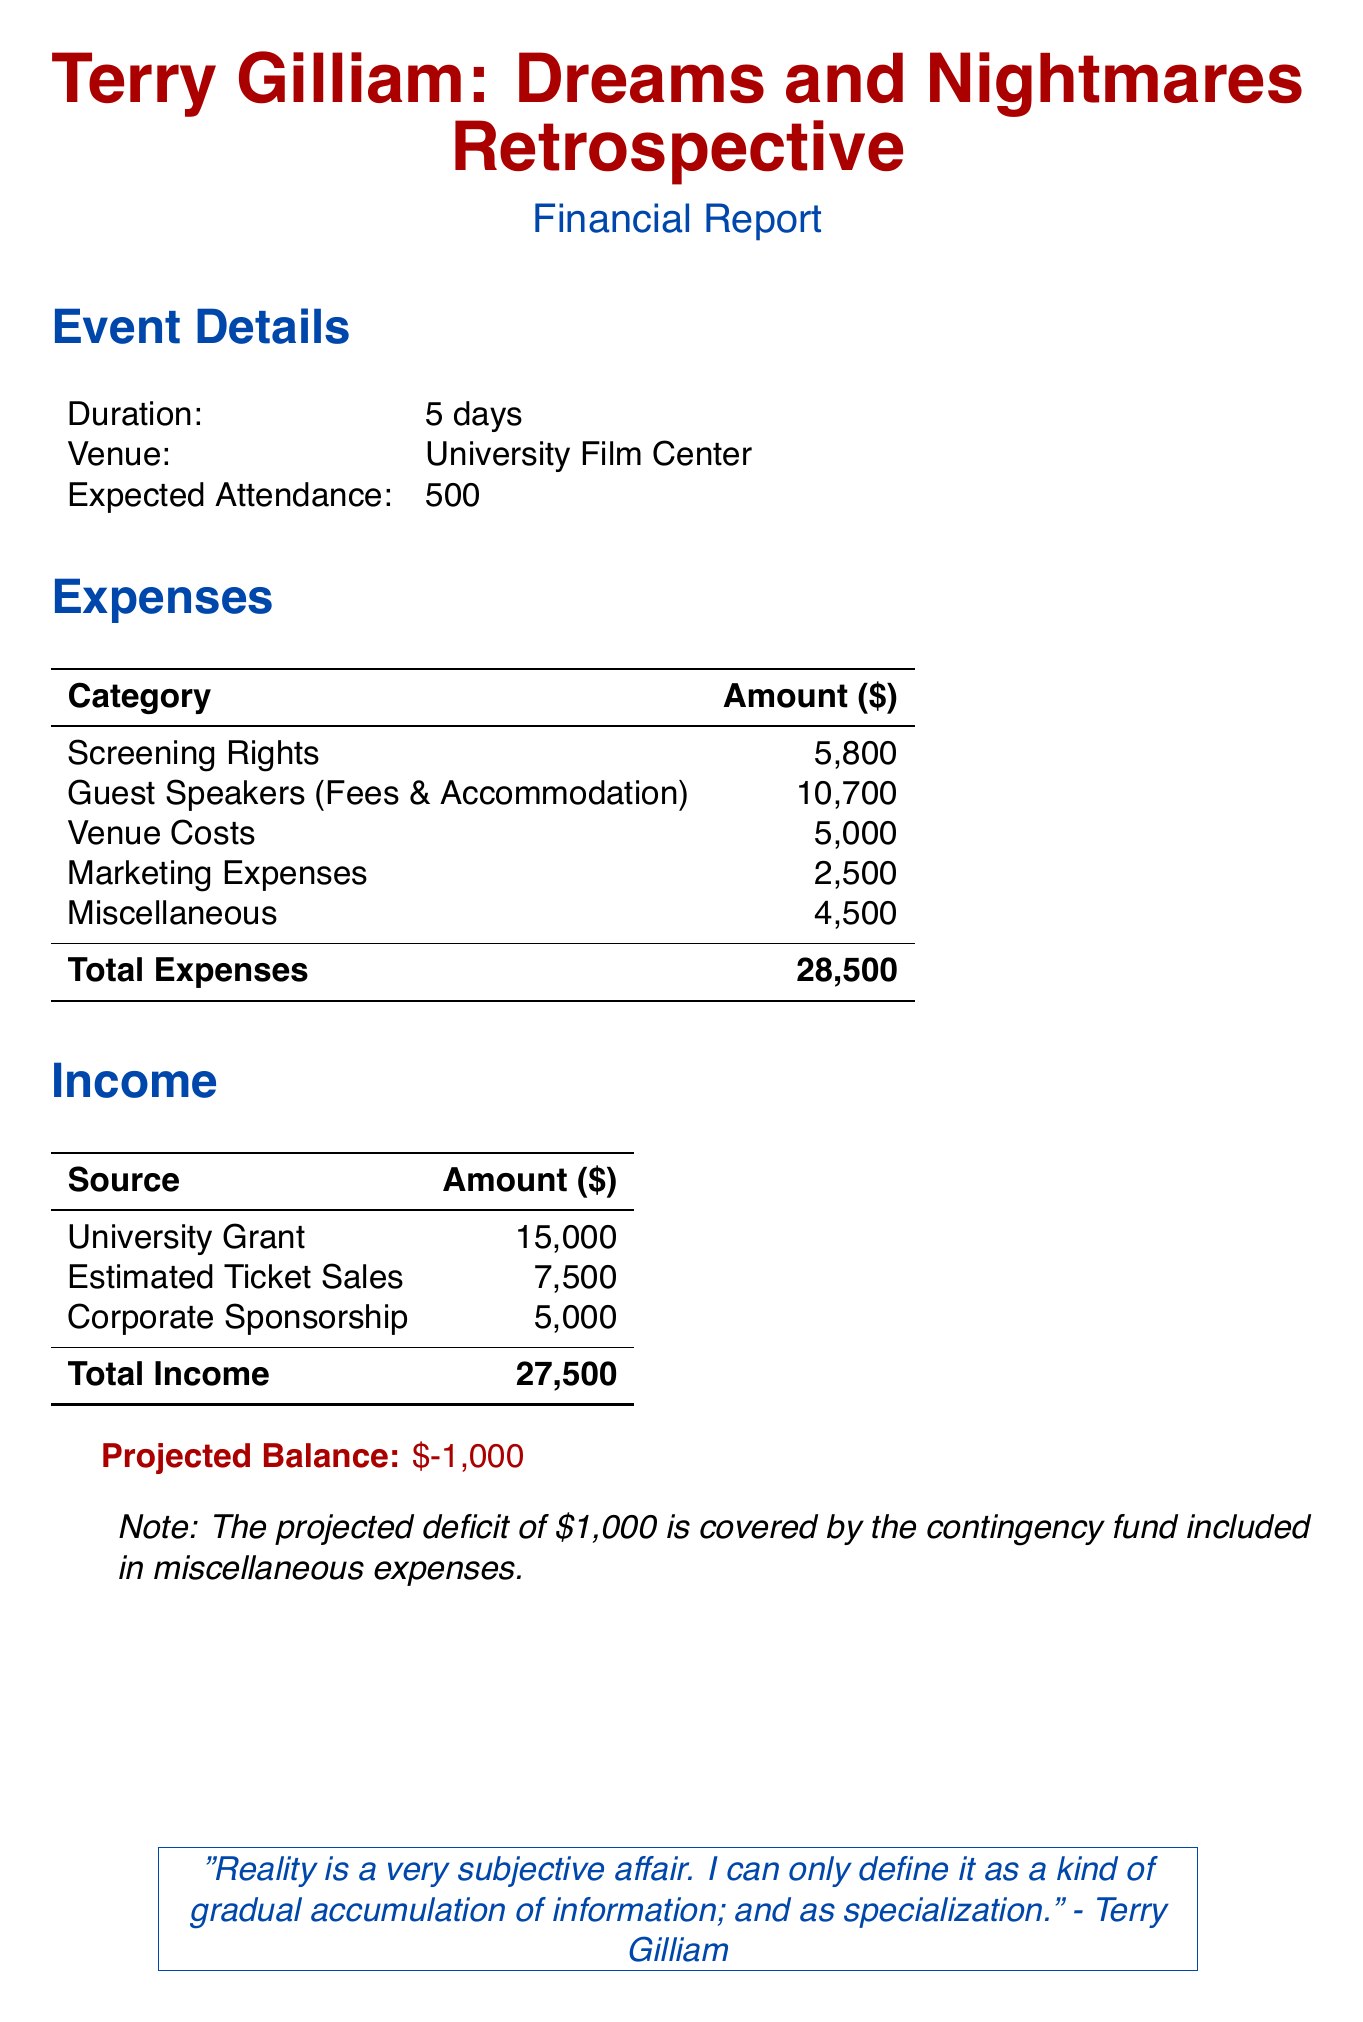What is the total cost for screening rights? The total cost for screening rights is calculated by adding the individual costs for each film listed in the document: 1200 + 1500 + 1000 + 1300 + 800 = 5800.
Answer: 5800 What is the fee for guest speaker Jonathan Pryce? The document specifies that Jonathan Pryce's fee is listed as 5000.
Answer: 5000 What is the venue rental cost? The venue cost section indicates that the rental cost is 2500.
Answer: 2500 What is the estimated number of attendees? The event details state that the expected attendance is 500.
Answer: 500 What is the total income? The total income is calculated from the sum of the three funding sources: 15000 + 7500 + 5000 = 27500.
Answer: 27500 What is the projected balance? The projected balance reflects a deficit, which is noted as -1000 in the financial report.
Answer: -1000 Which film has the highest screening rights cost? The film with the highest screening rights cost is "12 Monkeys" at a cost of 1500.
Answer: 12 Monkeys What are the total miscellaneous expenses? The miscellaneous expenses total is found by adding the costs in that category: 1500 + 1000 + 2000 = 4500.
Answer: 4500 How much is allocated for marketing expenses? The marketing expenses total is the sum of print materials, online advertising, and local media, which totals 2500.
Answer: 2500 